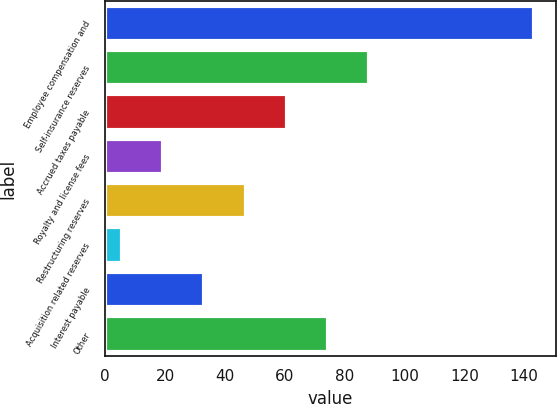<chart> <loc_0><loc_0><loc_500><loc_500><bar_chart><fcel>Employee compensation and<fcel>Self-insurance reserves<fcel>Accrued taxes payable<fcel>Royalty and license fees<fcel>Restructuring reserves<fcel>Acquisition related reserves<fcel>Interest payable<fcel>Other<nl><fcel>143.4<fcel>88.28<fcel>60.72<fcel>19.38<fcel>46.94<fcel>5.6<fcel>33.16<fcel>74.5<nl></chart> 